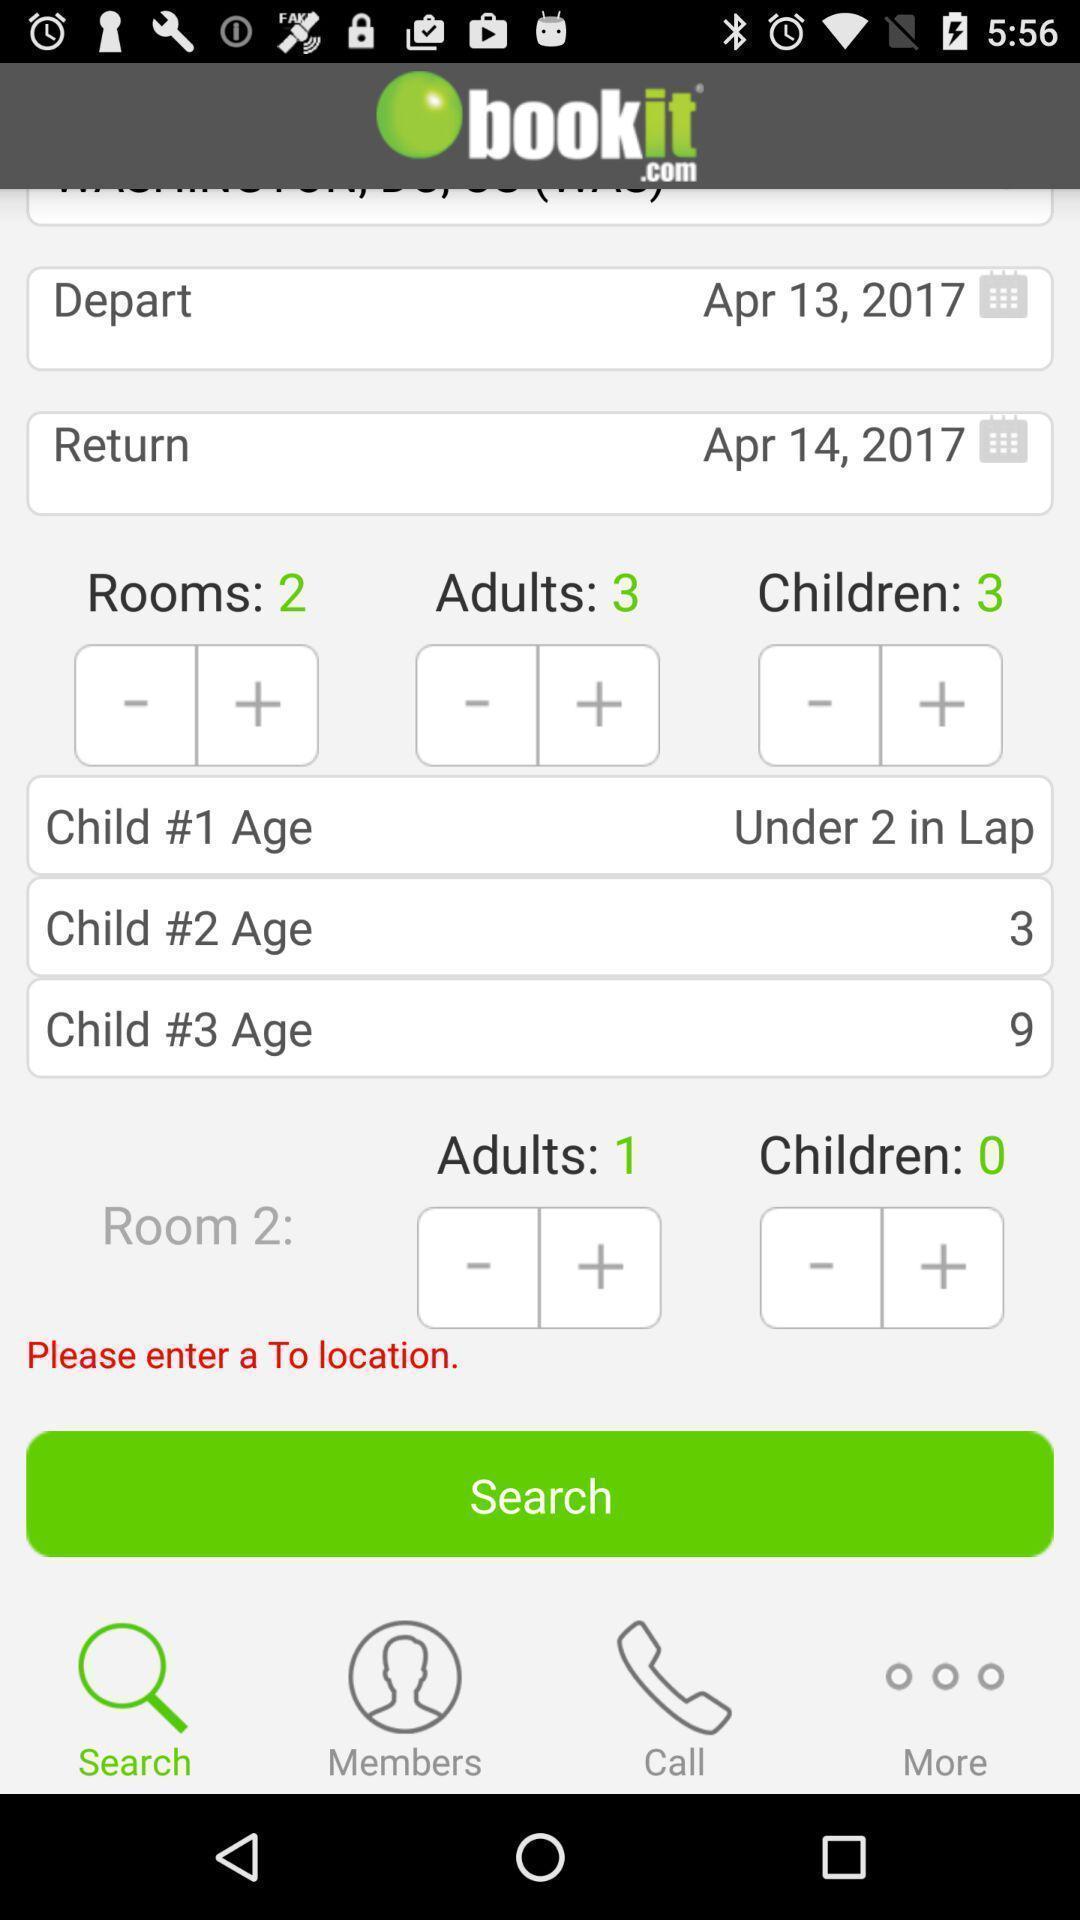Please provide a description for this image. Page showing schedule for journey. 